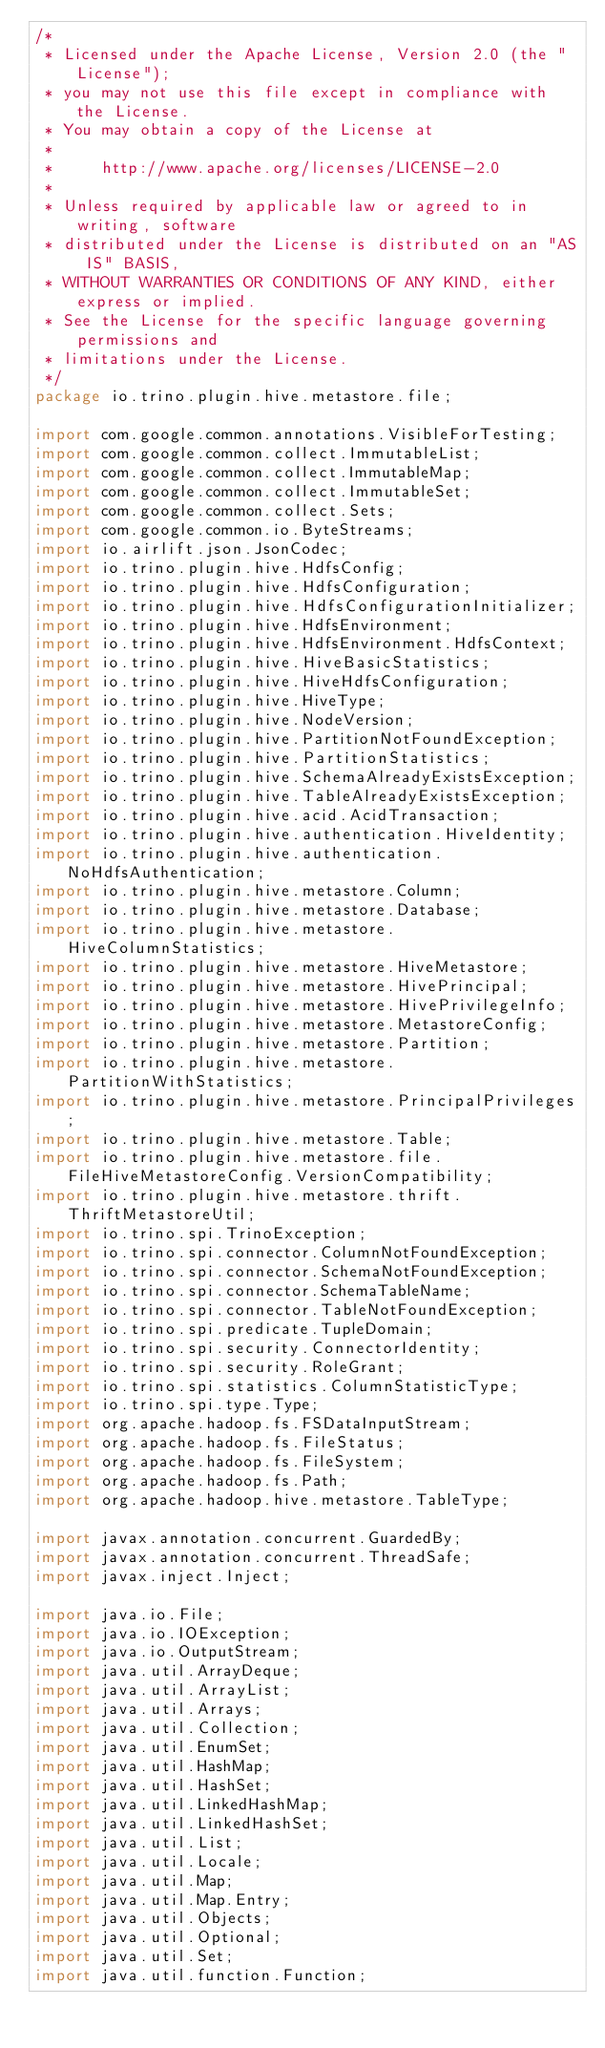<code> <loc_0><loc_0><loc_500><loc_500><_Java_>/*
 * Licensed under the Apache License, Version 2.0 (the "License");
 * you may not use this file except in compliance with the License.
 * You may obtain a copy of the License at
 *
 *     http://www.apache.org/licenses/LICENSE-2.0
 *
 * Unless required by applicable law or agreed to in writing, software
 * distributed under the License is distributed on an "AS IS" BASIS,
 * WITHOUT WARRANTIES OR CONDITIONS OF ANY KIND, either express or implied.
 * See the License for the specific language governing permissions and
 * limitations under the License.
 */
package io.trino.plugin.hive.metastore.file;

import com.google.common.annotations.VisibleForTesting;
import com.google.common.collect.ImmutableList;
import com.google.common.collect.ImmutableMap;
import com.google.common.collect.ImmutableSet;
import com.google.common.collect.Sets;
import com.google.common.io.ByteStreams;
import io.airlift.json.JsonCodec;
import io.trino.plugin.hive.HdfsConfig;
import io.trino.plugin.hive.HdfsConfiguration;
import io.trino.plugin.hive.HdfsConfigurationInitializer;
import io.trino.plugin.hive.HdfsEnvironment;
import io.trino.plugin.hive.HdfsEnvironment.HdfsContext;
import io.trino.plugin.hive.HiveBasicStatistics;
import io.trino.plugin.hive.HiveHdfsConfiguration;
import io.trino.plugin.hive.HiveType;
import io.trino.plugin.hive.NodeVersion;
import io.trino.plugin.hive.PartitionNotFoundException;
import io.trino.plugin.hive.PartitionStatistics;
import io.trino.plugin.hive.SchemaAlreadyExistsException;
import io.trino.plugin.hive.TableAlreadyExistsException;
import io.trino.plugin.hive.acid.AcidTransaction;
import io.trino.plugin.hive.authentication.HiveIdentity;
import io.trino.plugin.hive.authentication.NoHdfsAuthentication;
import io.trino.plugin.hive.metastore.Column;
import io.trino.plugin.hive.metastore.Database;
import io.trino.plugin.hive.metastore.HiveColumnStatistics;
import io.trino.plugin.hive.metastore.HiveMetastore;
import io.trino.plugin.hive.metastore.HivePrincipal;
import io.trino.plugin.hive.metastore.HivePrivilegeInfo;
import io.trino.plugin.hive.metastore.MetastoreConfig;
import io.trino.plugin.hive.metastore.Partition;
import io.trino.plugin.hive.metastore.PartitionWithStatistics;
import io.trino.plugin.hive.metastore.PrincipalPrivileges;
import io.trino.plugin.hive.metastore.Table;
import io.trino.plugin.hive.metastore.file.FileHiveMetastoreConfig.VersionCompatibility;
import io.trino.plugin.hive.metastore.thrift.ThriftMetastoreUtil;
import io.trino.spi.TrinoException;
import io.trino.spi.connector.ColumnNotFoundException;
import io.trino.spi.connector.SchemaNotFoundException;
import io.trino.spi.connector.SchemaTableName;
import io.trino.spi.connector.TableNotFoundException;
import io.trino.spi.predicate.TupleDomain;
import io.trino.spi.security.ConnectorIdentity;
import io.trino.spi.security.RoleGrant;
import io.trino.spi.statistics.ColumnStatisticType;
import io.trino.spi.type.Type;
import org.apache.hadoop.fs.FSDataInputStream;
import org.apache.hadoop.fs.FileStatus;
import org.apache.hadoop.fs.FileSystem;
import org.apache.hadoop.fs.Path;
import org.apache.hadoop.hive.metastore.TableType;

import javax.annotation.concurrent.GuardedBy;
import javax.annotation.concurrent.ThreadSafe;
import javax.inject.Inject;

import java.io.File;
import java.io.IOException;
import java.io.OutputStream;
import java.util.ArrayDeque;
import java.util.ArrayList;
import java.util.Arrays;
import java.util.Collection;
import java.util.EnumSet;
import java.util.HashMap;
import java.util.HashSet;
import java.util.LinkedHashMap;
import java.util.LinkedHashSet;
import java.util.List;
import java.util.Locale;
import java.util.Map;
import java.util.Map.Entry;
import java.util.Objects;
import java.util.Optional;
import java.util.Set;
import java.util.function.Function;</code> 